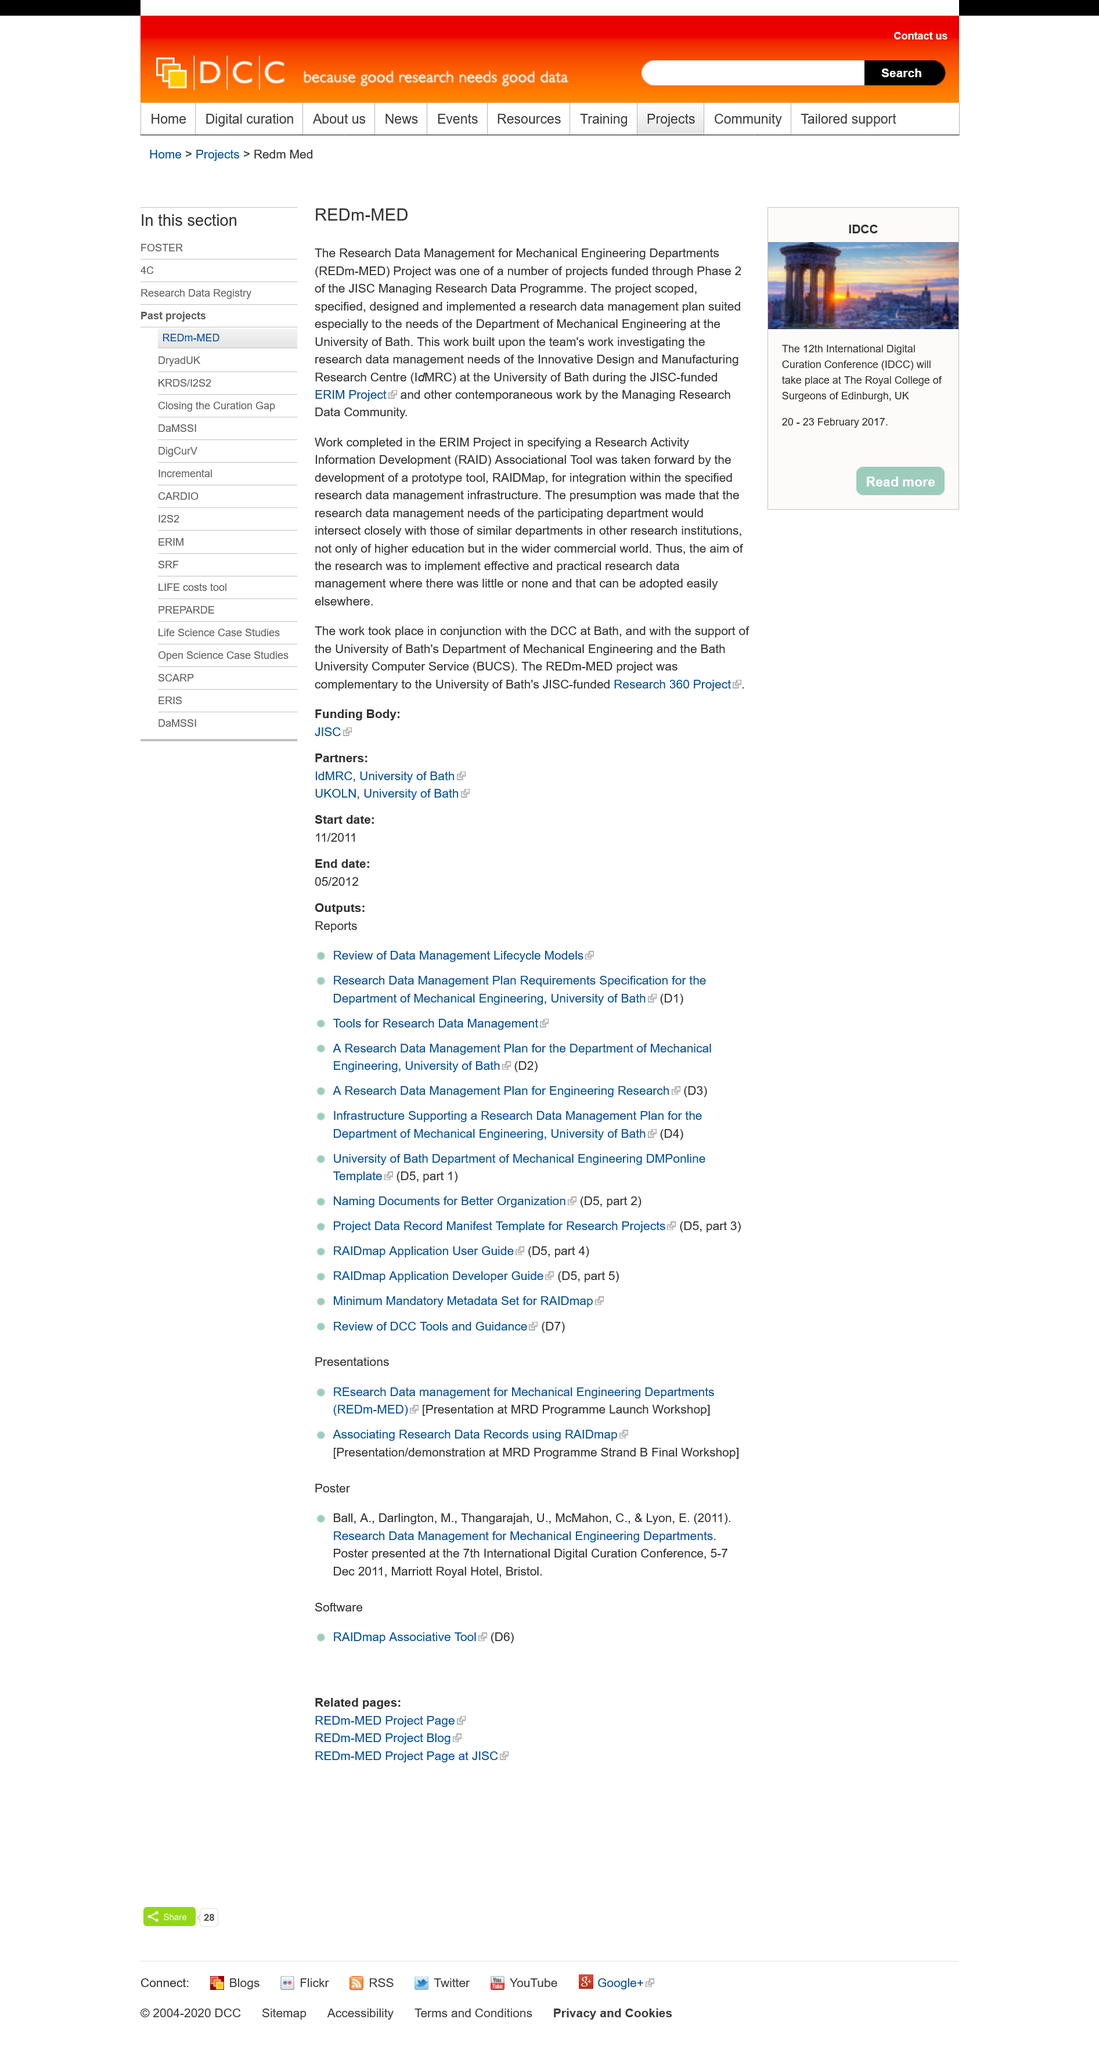Indicate a few pertinent items in this graphic. The Inovative Design and Manufacturing Research Centre is located at the University of Bath. The acronym "REDm-MED" stands for "The Research Management for Mechanical Engineering Departments. The REDm-MED project was funded through Phase 2 of the JISC Managing Research Data Programme. 